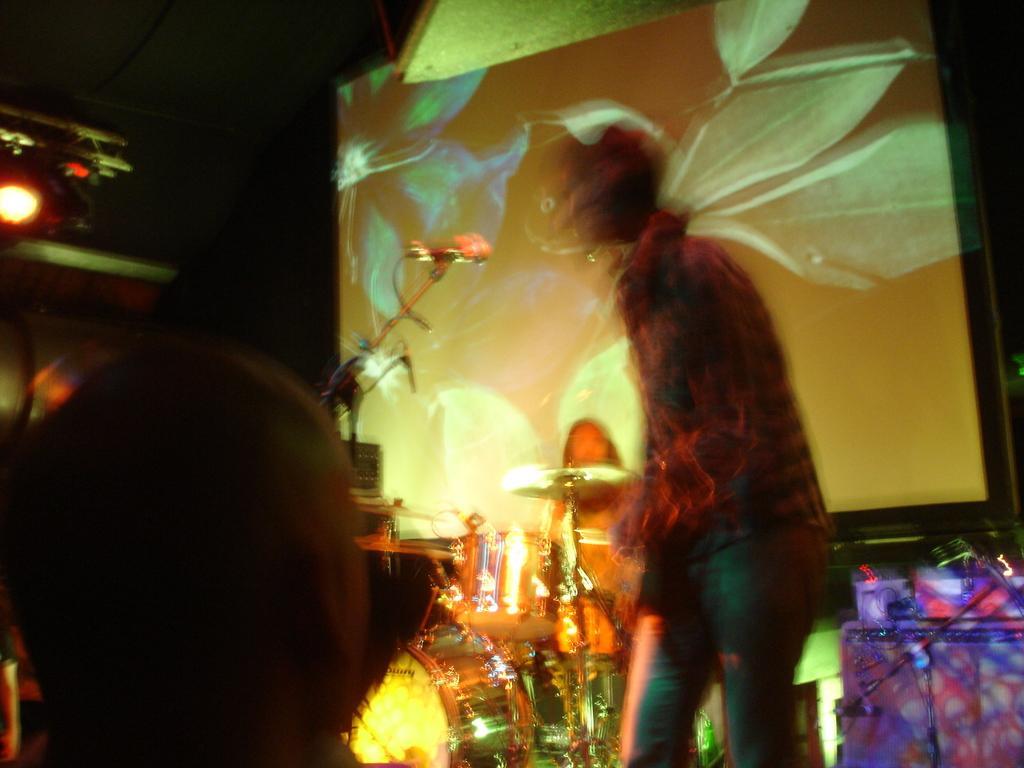Please provide a concise description of this image. In this image I can see few people. To the side I can see the musical instruments and mic. In the background I can see the screen and lights. 